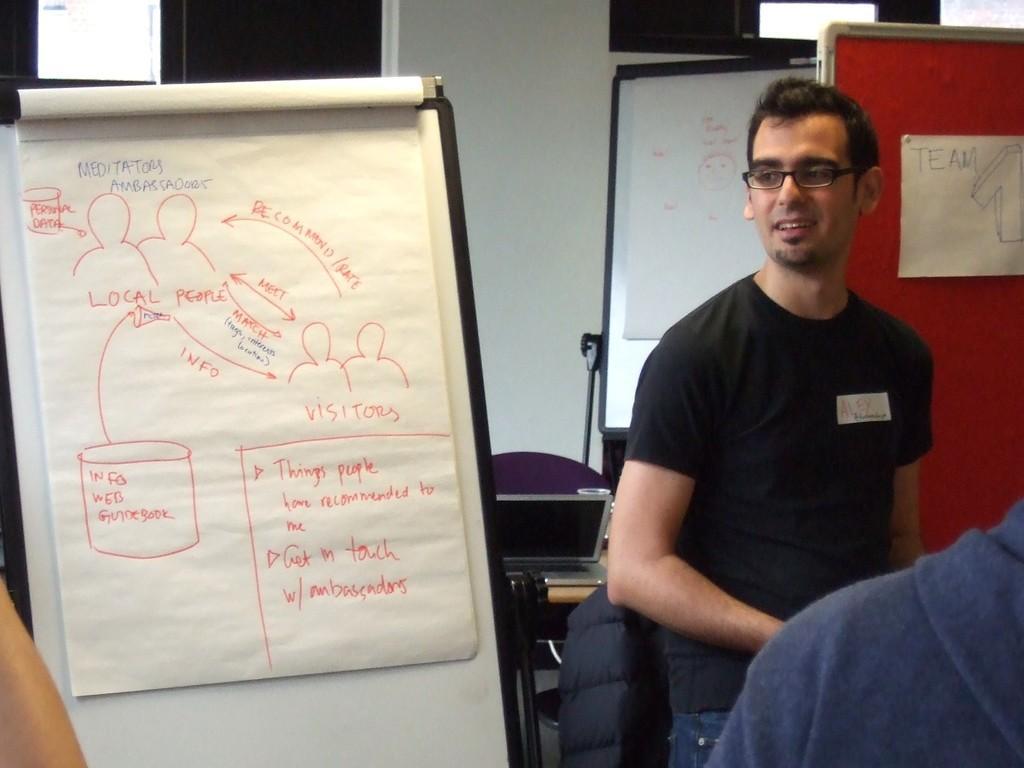Please provide a concise description of this image. In this image, we can see people and there are boards and some papers with text and we can see pictures on them. In the background, there is a wall and we can see a laptop and some other objects on the stand. 